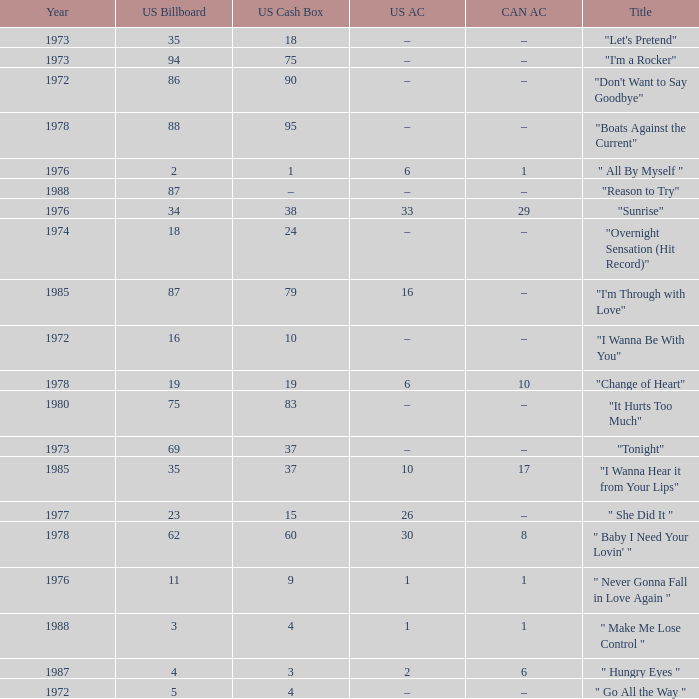What is the US cash box before 1978 with a US billboard of 35? 18.0. Would you be able to parse every entry in this table? {'header': ['Year', 'US Billboard', 'US Cash Box', 'US AC', 'CAN AC', 'Title'], 'rows': [['1973', '35', '18', '–', '–', '"Let\'s Pretend"'], ['1973', '94', '75', '–', '–', '"I\'m a Rocker"'], ['1972', '86', '90', '–', '–', '"Don\'t Want to Say Goodbye"'], ['1978', '88', '95', '–', '–', '"Boats Against the Current"'], ['1976', '2', '1', '6', '1', '" All By Myself "'], ['1988', '87', '–', '–', '–', '"Reason to Try"'], ['1976', '34', '38', '33', '29', '"Sunrise"'], ['1974', '18', '24', '–', '–', '"Overnight Sensation (Hit Record)"'], ['1985', '87', '79', '16', '–', '"I\'m Through with Love"'], ['1972', '16', '10', '–', '–', '"I Wanna Be With You"'], ['1978', '19', '19', '6', '10', '"Change of Heart"'], ['1980', '75', '83', '–', '–', '"It Hurts Too Much"'], ['1973', '69', '37', '–', '–', '"Tonight"'], ['1985', '35', '37', '10', '17', '"I Wanna Hear it from Your Lips"'], ['1977', '23', '15', '26', '–', '" She Did It "'], ['1978', '62', '60', '30', '8', '" Baby I Need Your Lovin\' "'], ['1976', '11', '9', '1', '1', '" Never Gonna Fall in Love Again "'], ['1988', '3', '4', '1', '1', '" Make Me Lose Control "'], ['1987', '4', '3', '2', '6', '" Hungry Eyes "'], ['1972', '5', '4', '–', '–', '" Go All the Way "']]} 